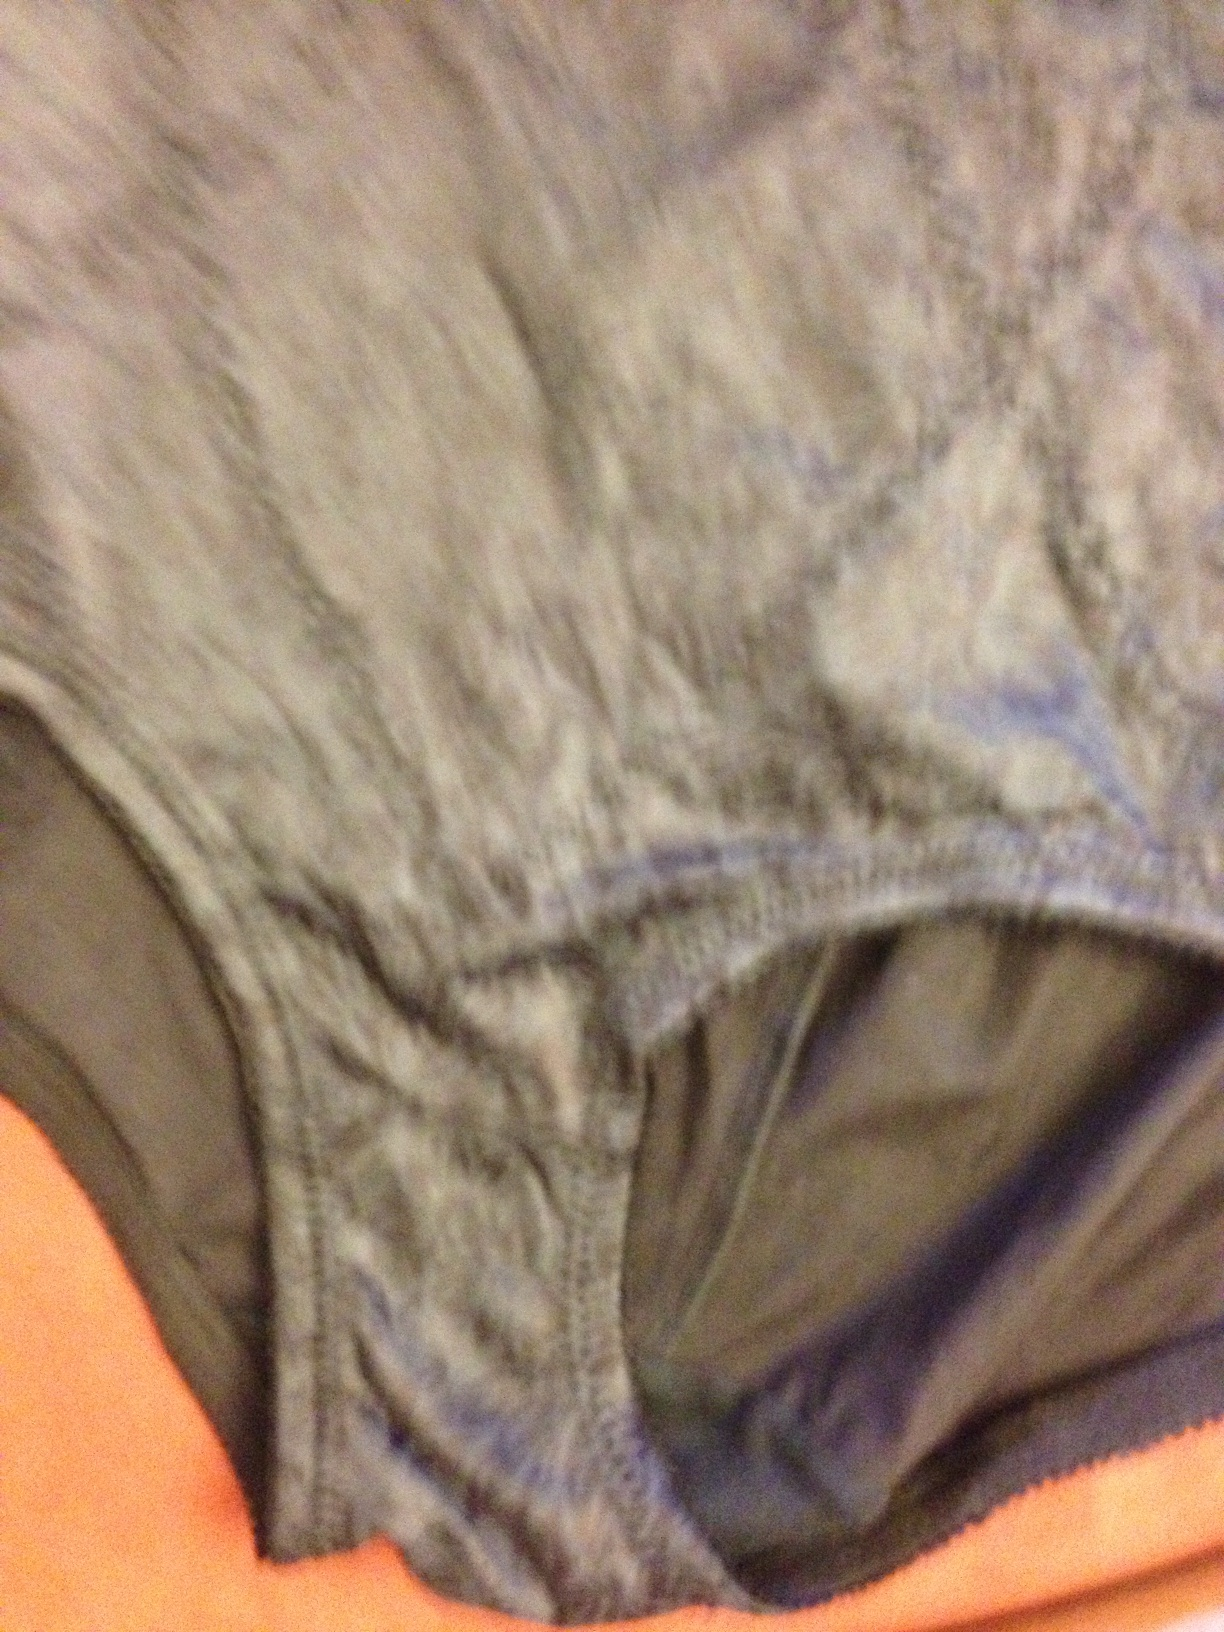What is the potential use for the type of fabric seen in the image? This type of fabric is generally used for making comfortable, everyday wear underwear, providing breathability and stretch for better fit and movement. 